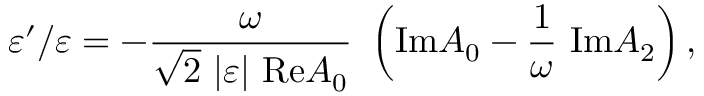<formula> <loc_0><loc_0><loc_500><loc_500>\varepsilon ^ { \prime } / \varepsilon = - { \frac { \omega } { \sqrt { 2 } | \varepsilon | R e A _ { 0 } } } \left ( I m A _ { 0 } - { \frac { 1 } { \omega } } I m A _ { 2 } \right ) ,</formula> 